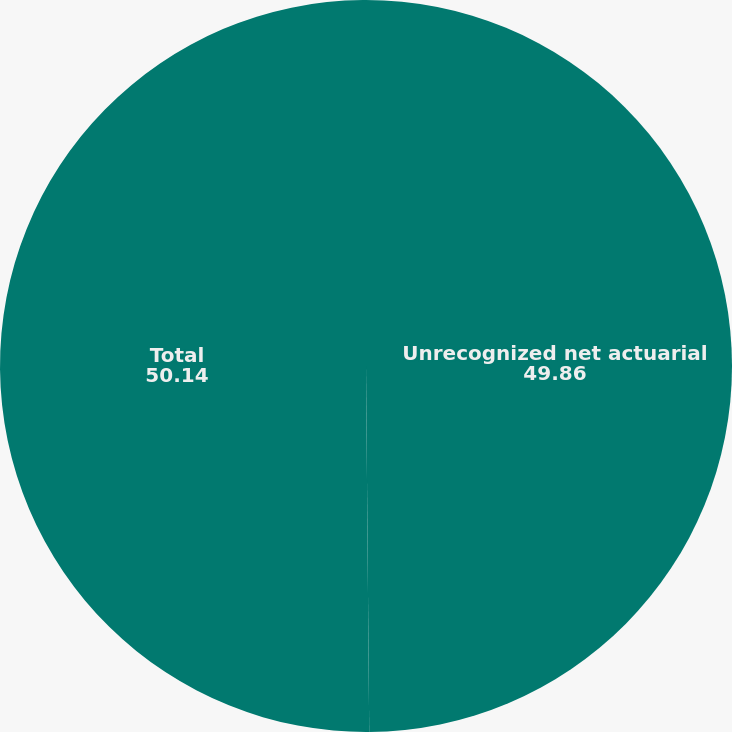<chart> <loc_0><loc_0><loc_500><loc_500><pie_chart><fcel>Unrecognized net actuarial<fcel>Total<nl><fcel>49.86%<fcel>50.14%<nl></chart> 